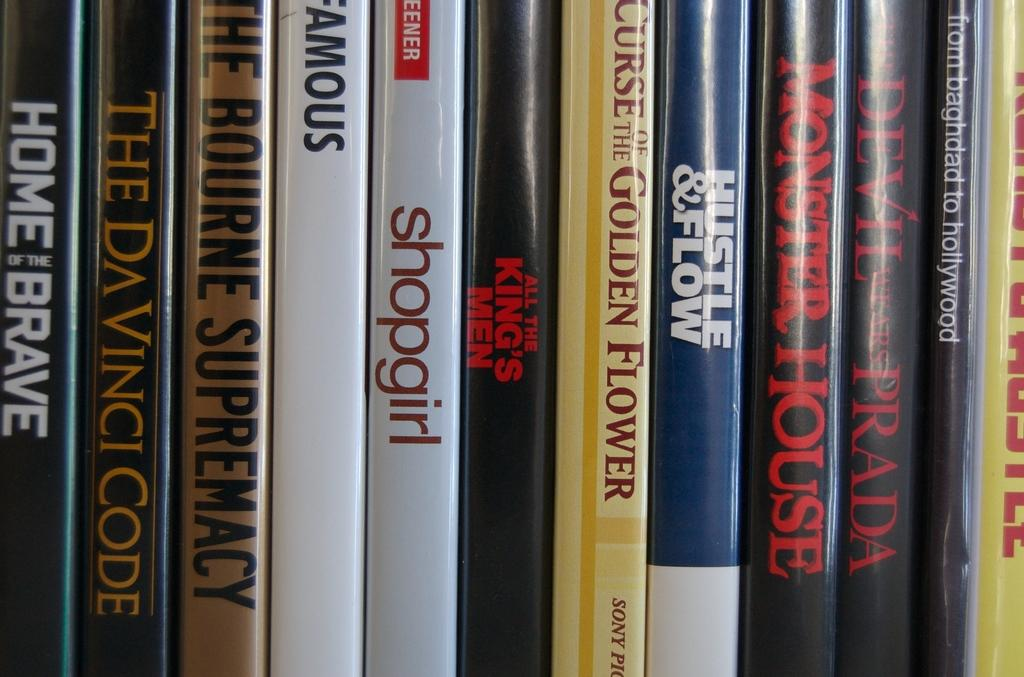<image>
Provide a brief description of the given image. A row of DVDs include titles such as Monster House, Hustle & Flow, and Home of the Brave. 